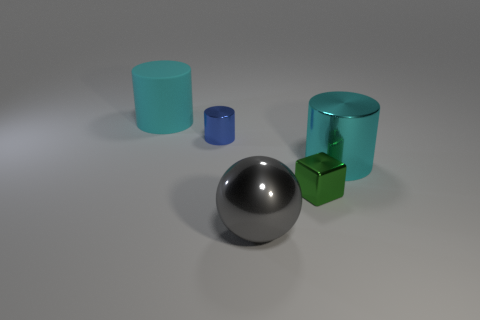Add 1 large metallic objects. How many objects exist? 6 Subtract all balls. How many objects are left? 4 Subtract all large purple shiny cylinders. Subtract all gray objects. How many objects are left? 4 Add 3 cyan cylinders. How many cyan cylinders are left? 5 Add 2 yellow cubes. How many yellow cubes exist? 2 Subtract 0 gray cylinders. How many objects are left? 5 